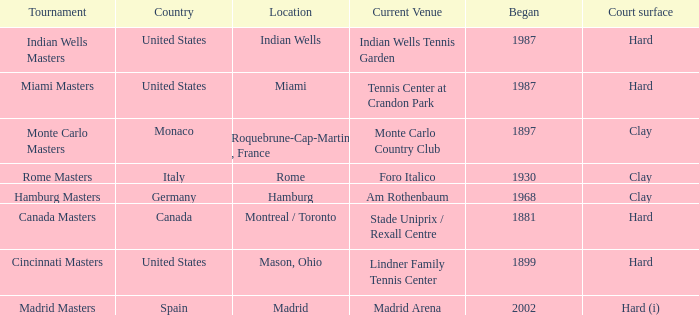How many tournaments have their current venue as the Lindner Family Tennis Center? 1.0. 